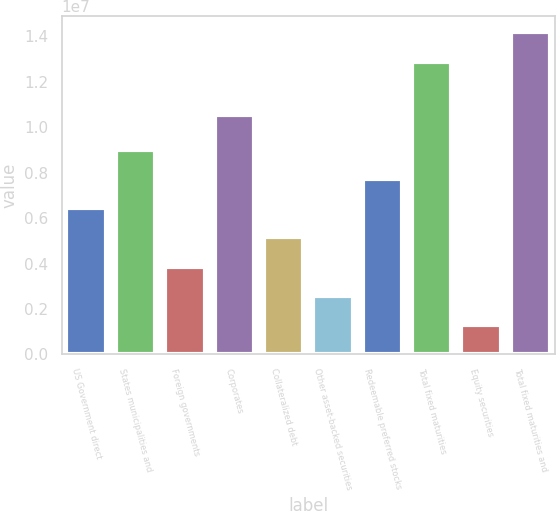Convert chart to OTSL. <chart><loc_0><loc_0><loc_500><loc_500><bar_chart><fcel>US Government direct<fcel>States municipalities and<fcel>Foreign governments<fcel>Corporates<fcel>Collateralized debt<fcel>Other asset-backed securities<fcel>Redeemable preferred stocks<fcel>Total fixed maturities<fcel>Equity securities<fcel>Total fixed maturities and<nl><fcel>6.44056e+06<fcel>9.01674e+06<fcel>3.86438e+06<fcel>1.05363e+07<fcel>5.15247e+06<fcel>2.57628e+06<fcel>7.72865e+06<fcel>1.28791e+07<fcel>1.28819e+06<fcel>1.41672e+07<nl></chart> 